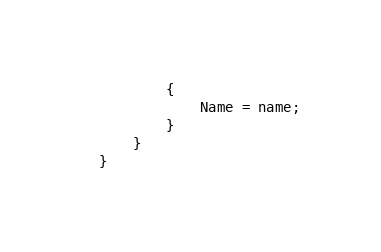Convert code to text. <code><loc_0><loc_0><loc_500><loc_500><_C#_>        {
            Name = name;
        }
    }
}
</code> 